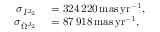Convert formula to latex. <formula><loc_0><loc_0><loc_500><loc_500>\begin{array} { r l } { \sigma _ { \dot { I } ^ { J _ { 2 } } } } & = 3 2 4 \, 2 2 0 \, m a s \, y r ^ { - 1 } , } \\ { \sigma _ { \dot { \Omega } ^ { J _ { 2 } } } } & = 8 7 \, 9 1 8 \, m a s \, y r ^ { - 1 } , } \end{array}</formula> 